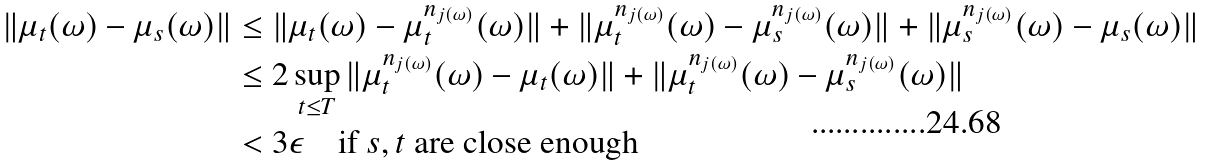Convert formula to latex. <formula><loc_0><loc_0><loc_500><loc_500>\| \mu _ { t } ( \omega ) - \mu _ { s } ( \omega ) \| & \leq \| \mu _ { t } ( \omega ) - \mu _ { t } ^ { n _ { j ( \omega ) } } ( \omega ) \| + \| \mu _ { t } ^ { n _ { j ( \omega ) } } ( \omega ) - \mu _ { s } ^ { n _ { j ( \omega ) } } ( \omega ) \| + \| \mu _ { s } ^ { n _ { j ( \omega ) } } ( \omega ) - \mu _ { s } ( \omega ) \| \\ & \leq 2 \sup _ { t \leq T } \| \mu _ { t } ^ { n _ { j ( \omega ) } } ( \omega ) - \mu _ { t } ( \omega ) \| + \| \mu _ { t } ^ { n _ { j ( \omega ) } } ( \omega ) - \mu _ { s } ^ { n _ { j ( \omega ) } } ( \omega ) \| \\ & < 3 \epsilon \quad \text {if $s,t$ are close enough}</formula> 